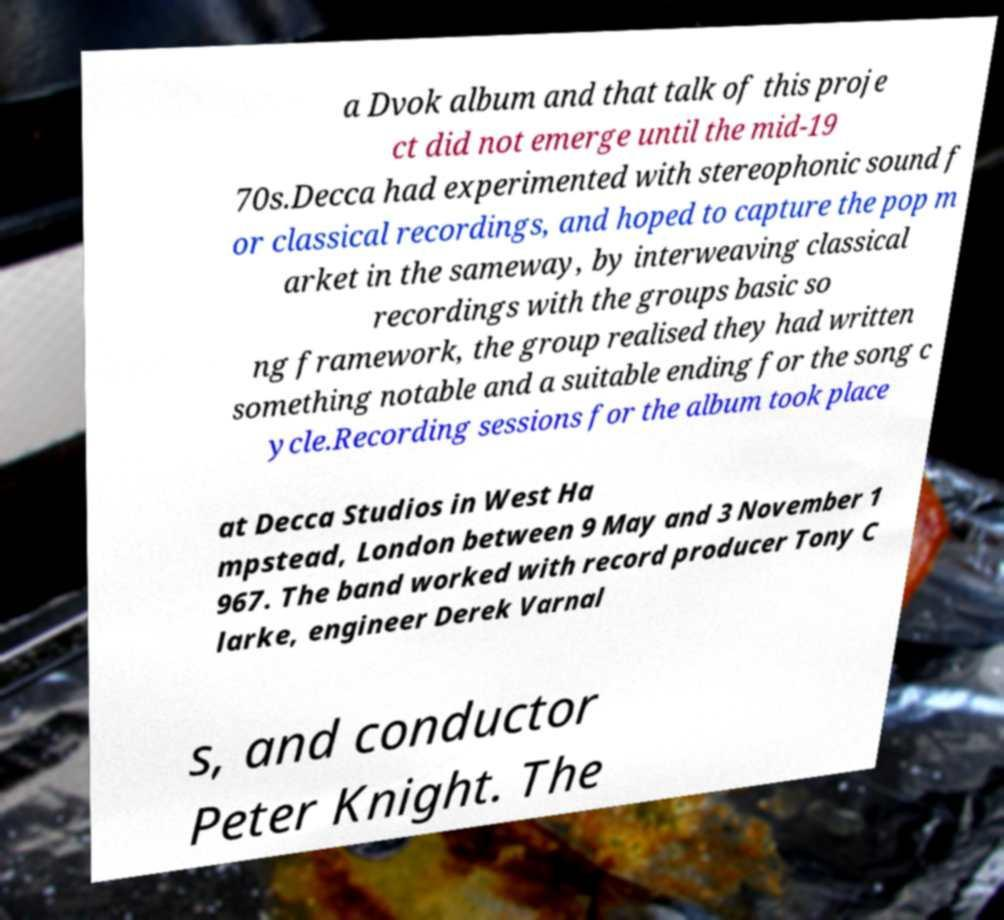Please read and relay the text visible in this image. What does it say? a Dvok album and that talk of this proje ct did not emerge until the mid-19 70s.Decca had experimented with stereophonic sound f or classical recordings, and hoped to capture the pop m arket in the sameway, by interweaving classical recordings with the groups basic so ng framework, the group realised they had written something notable and a suitable ending for the song c ycle.Recording sessions for the album took place at Decca Studios in West Ha mpstead, London between 9 May and 3 November 1 967. The band worked with record producer Tony C larke, engineer Derek Varnal s, and conductor Peter Knight. The 